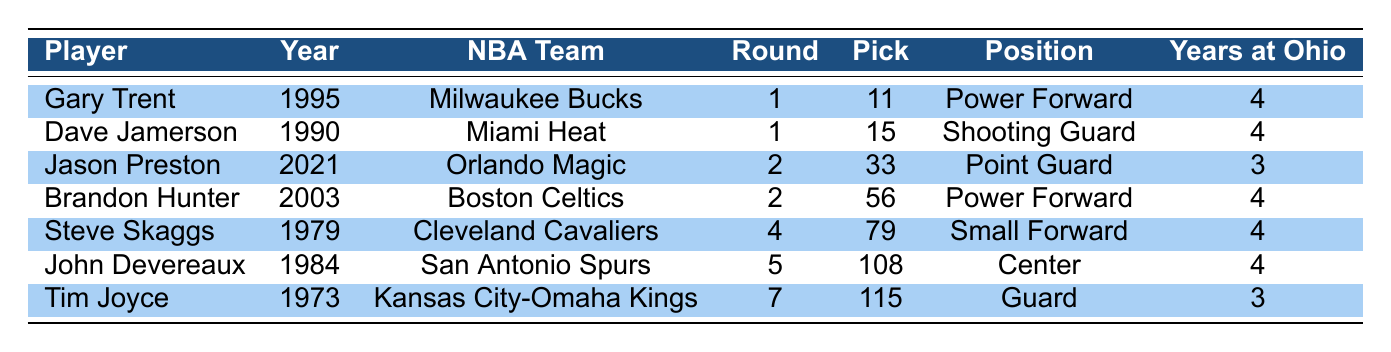What year was Gary Trent drafted? Gary Trent is listed in the table, and his "Year Drafted" is provided as 1995.
Answer: 1995 Which NBA team drafted Dave Jamerson? The table indicates that Dave Jamerson was drafted by the Miami Heat.
Answer: Miami Heat How many years did Jason Preston play at Ohio? Referring to Jason Preston's entry, it states he played at Ohio for 3 years.
Answer: 3 years What position did Brandon Hunter play? In the table, Brandon Hunter is listed with the position of Power Forward.
Answer: Power Forward Which player was drafted in the 2nd round? There are two players listed in the table who were drafted in the 2nd round: Jason Preston (2021) and Brandon Hunter (2003).
Answer: Jason Preston and Brandon Hunter What is the average draft pick of players drafted in the 1st round? The 1st round picks in the table are 11 (Gary Trent) and 15 (Dave Jamerson). The average is calculated as (11 + 15) / 2 = 13.
Answer: 13 Was any player drafted by the Cleveland Cavaliers? The table shows Steve Skaggs was drafted by the Cleveland Cavaliers, confirming the statement is true.
Answer: Yes Which player was drafted latest and what team drafted him? The latest drafted player in the table is Jason Preston, drafted in 2021 by the Orlando Magic.
Answer: Jason Preston, Orlando Magic What is the difference in draft pick numbers between Gary Trent and Jason Preston? Gary Trent's draft pick is 11 and Jason Preston's is 33. The difference is 33 - 11 = 22.
Answer: 22 How many players from Ohio were drafted to the NBA in the 1980s? In the table, there are two players from the 1980s: Dave Jamerson (1990) and John Devereaux (1984). Therefore, the answer is two.
Answer: Two 